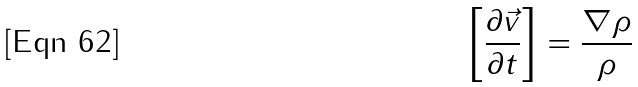<formula> <loc_0><loc_0><loc_500><loc_500>\left [ \frac { \partial \vec { v } } { \partial t } \right ] = \frac { \nabla \rho } { \rho }</formula> 